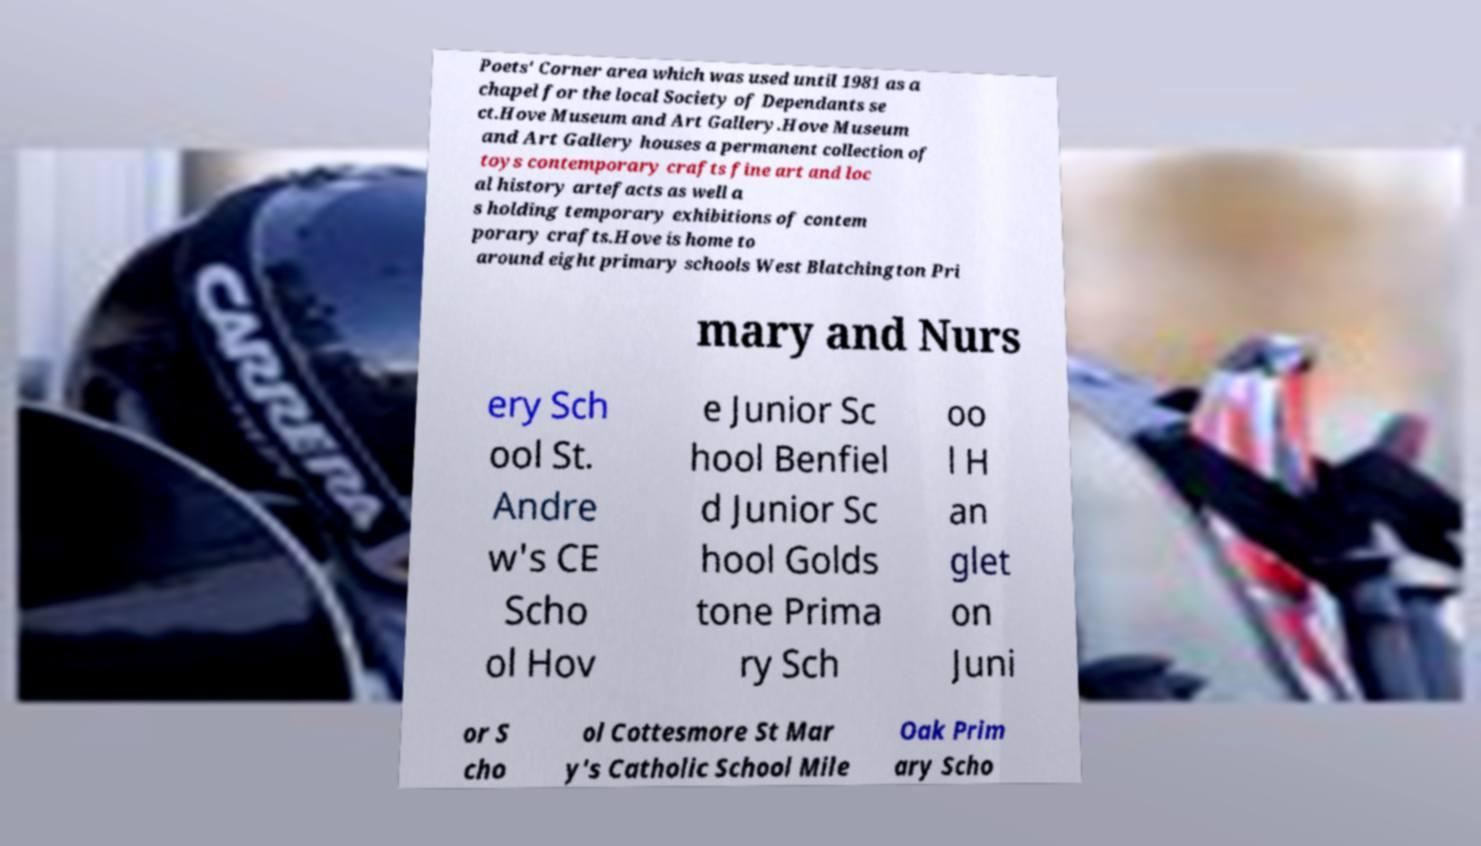Could you assist in decoding the text presented in this image and type it out clearly? Poets' Corner area which was used until 1981 as a chapel for the local Society of Dependants se ct.Hove Museum and Art Gallery.Hove Museum and Art Gallery houses a permanent collection of toys contemporary crafts fine art and loc al history artefacts as well a s holding temporary exhibitions of contem porary crafts.Hove is home to around eight primary schools West Blatchington Pri mary and Nurs ery Sch ool St. Andre w's CE Scho ol Hov e Junior Sc hool Benfiel d Junior Sc hool Golds tone Prima ry Sch oo l H an glet on Juni or S cho ol Cottesmore St Mar y's Catholic School Mile Oak Prim ary Scho 